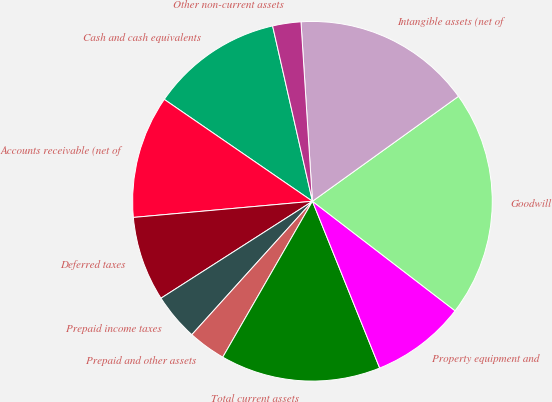Convert chart. <chart><loc_0><loc_0><loc_500><loc_500><pie_chart><fcel>Cash and cash equivalents<fcel>Accounts receivable (net of<fcel>Deferred taxes<fcel>Prepaid income taxes<fcel>Prepaid and other assets<fcel>Total current assets<fcel>Property equipment and<fcel>Goodwill<fcel>Intangible assets (net of<fcel>Other non-current assets<nl><fcel>11.86%<fcel>11.02%<fcel>7.63%<fcel>4.24%<fcel>3.39%<fcel>14.41%<fcel>8.48%<fcel>20.34%<fcel>16.1%<fcel>2.54%<nl></chart> 